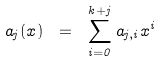<formula> <loc_0><loc_0><loc_500><loc_500>a _ { j } ( x ) \ = \ \sum _ { i = 0 } ^ { k + j } a _ { j , i } x ^ { i }</formula> 